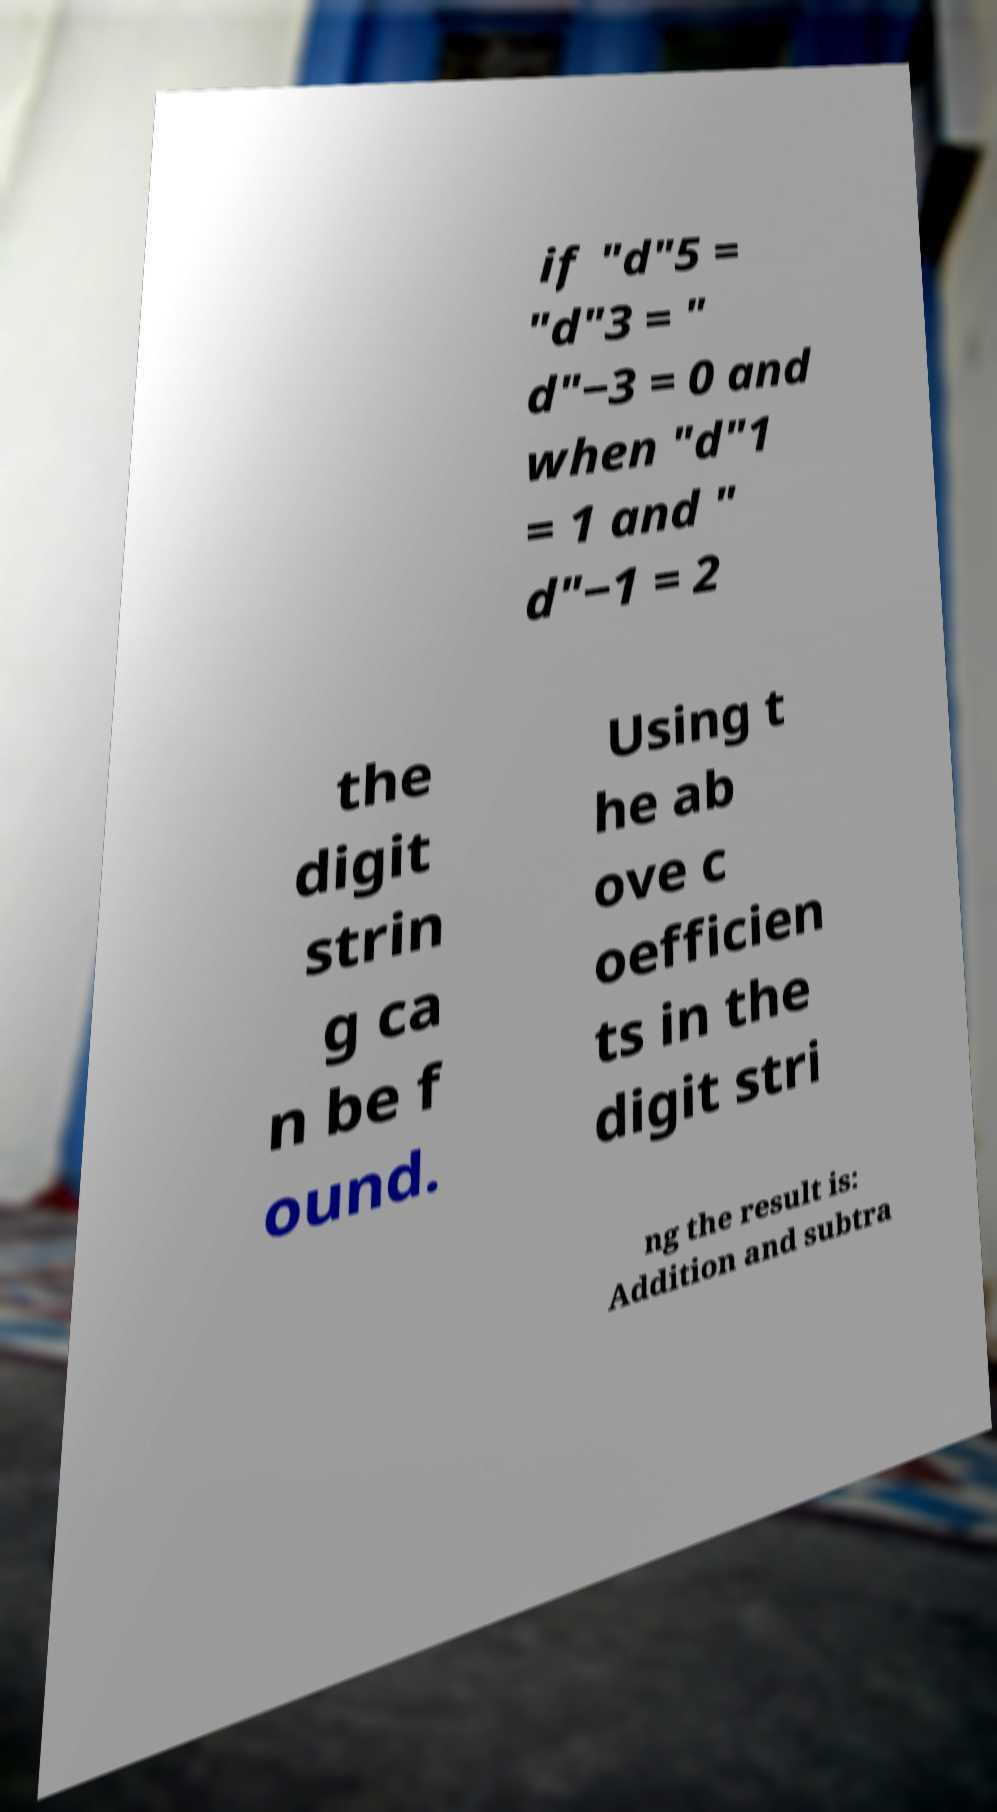Can you accurately transcribe the text from the provided image for me? if "d"5 = "d"3 = " d"−3 = 0 and when "d"1 = 1 and " d"−1 = 2 the digit strin g ca n be f ound. Using t he ab ove c oefficien ts in the digit stri ng the result is: Addition and subtra 